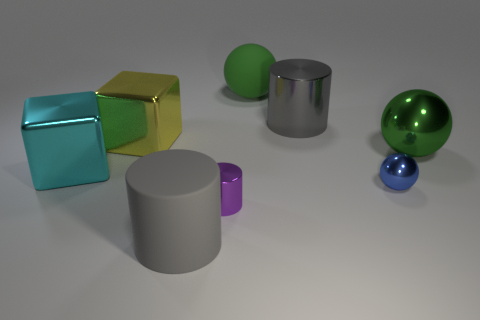How many green spheres must be subtracted to get 1 green spheres? 1 Subtract all brown cylinders. How many green balls are left? 2 Subtract all shiny balls. How many balls are left? 1 Add 1 big red matte objects. How many objects exist? 9 Subtract all purple spheres. Subtract all yellow cylinders. How many spheres are left? 3 Add 2 red metallic balls. How many red metallic balls exist? 2 Subtract 2 green spheres. How many objects are left? 6 Subtract all blocks. How many objects are left? 6 Subtract all small red cylinders. Subtract all large cyan things. How many objects are left? 7 Add 6 big cyan metal blocks. How many big cyan metal blocks are left? 7 